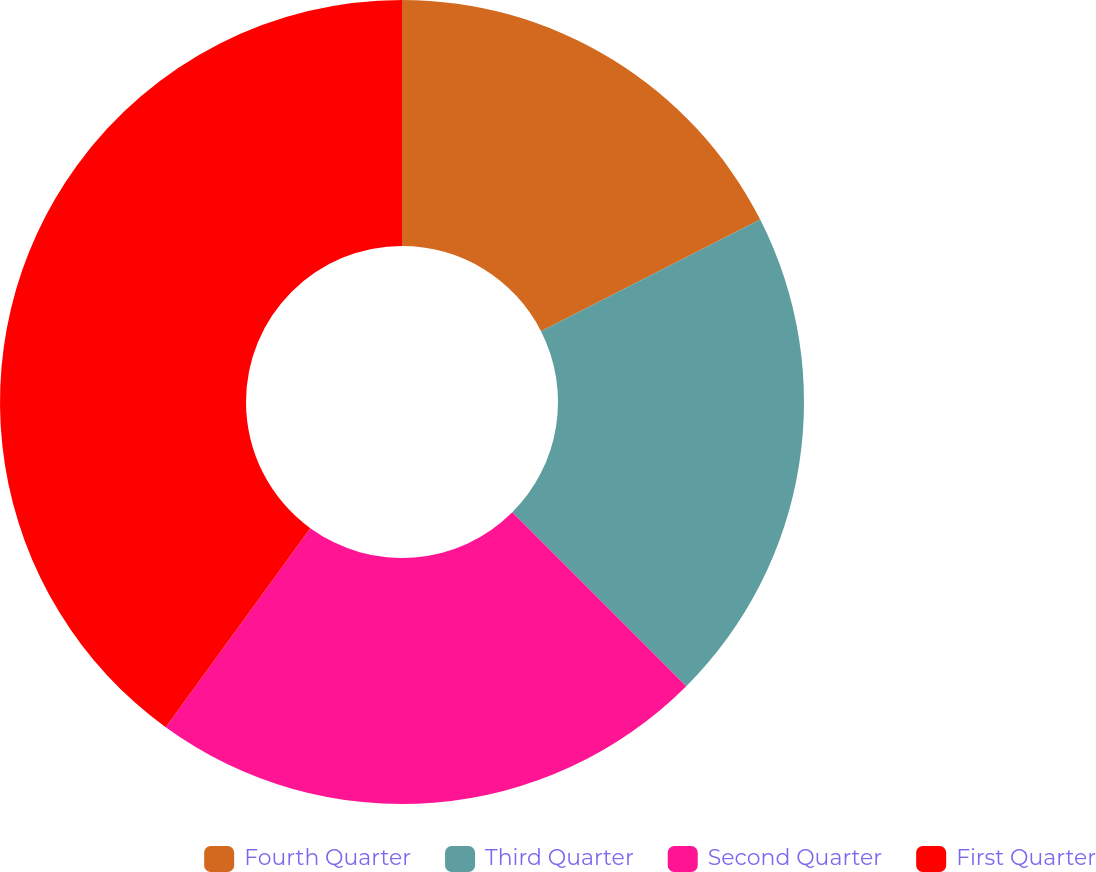<chart> <loc_0><loc_0><loc_500><loc_500><pie_chart><fcel>Fourth Quarter<fcel>Third Quarter<fcel>Second Quarter<fcel>First Quarter<nl><fcel>17.5%<fcel>20.0%<fcel>22.5%<fcel>40.0%<nl></chart> 